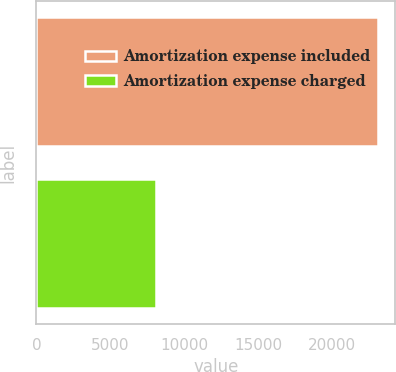Convert chart to OTSL. <chart><loc_0><loc_0><loc_500><loc_500><bar_chart><fcel>Amortization expense included<fcel>Amortization expense charged<nl><fcel>23104<fcel>8096<nl></chart> 